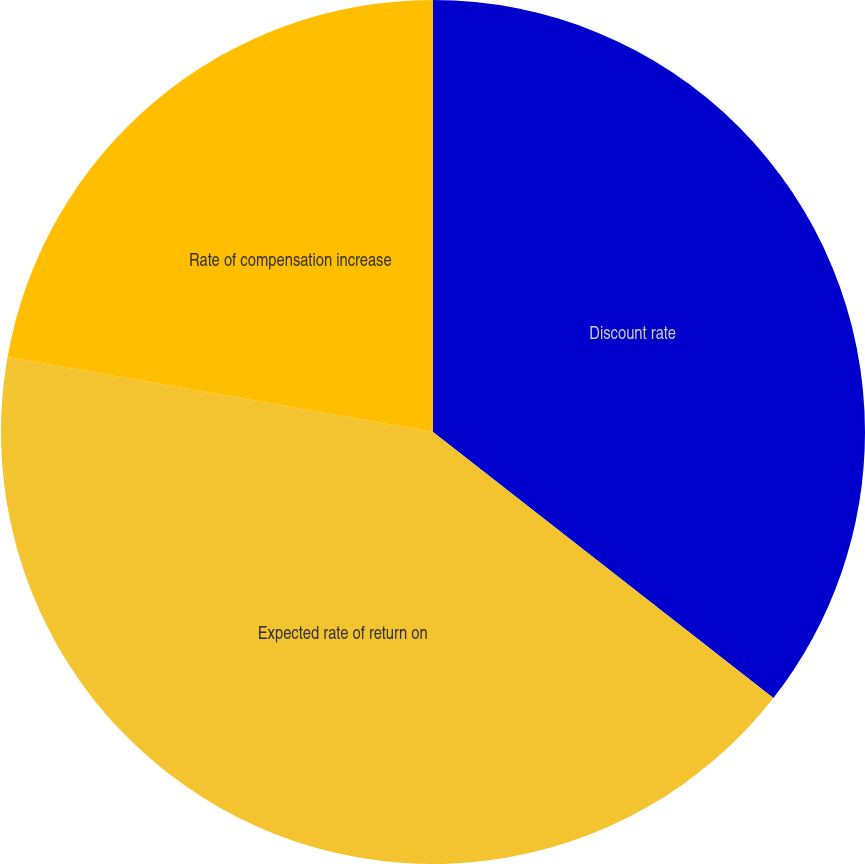<chart> <loc_0><loc_0><loc_500><loc_500><pie_chart><fcel>Discount rate<fcel>Expected rate of return on<fcel>Rate of compensation increase<nl><fcel>35.56%<fcel>42.22%<fcel>22.22%<nl></chart> 